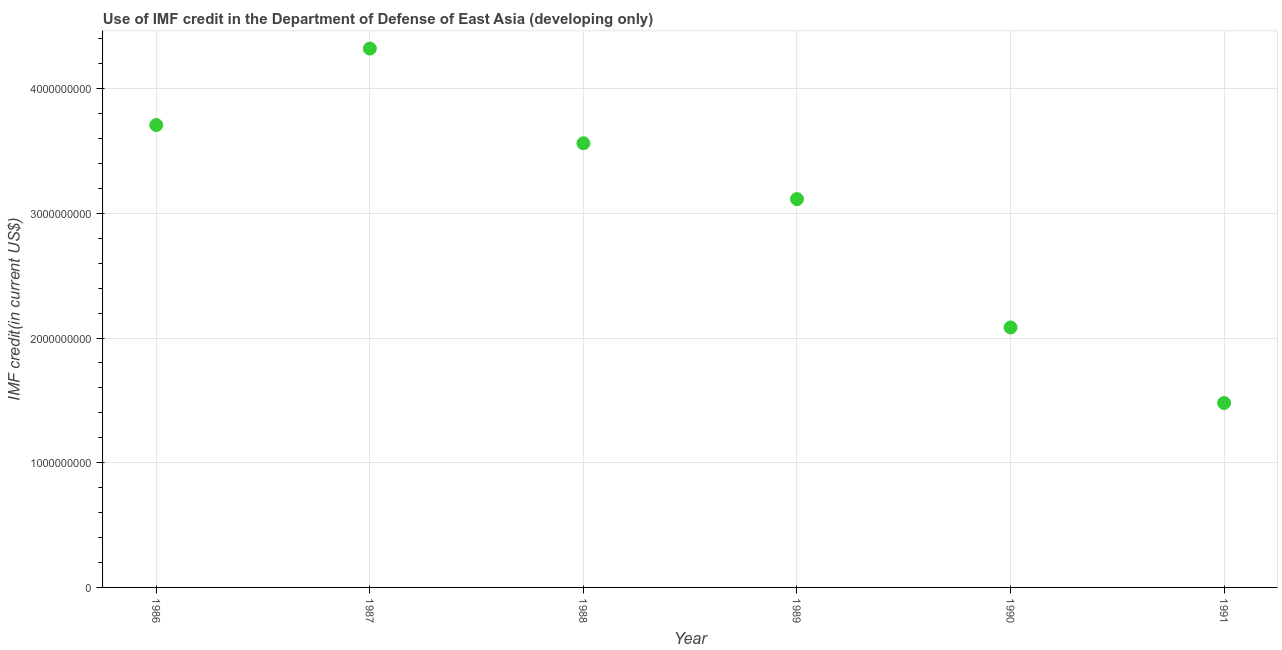What is the use of imf credit in dod in 1990?
Your answer should be very brief. 2.08e+09. Across all years, what is the maximum use of imf credit in dod?
Provide a succinct answer. 4.32e+09. Across all years, what is the minimum use of imf credit in dod?
Offer a very short reply. 1.48e+09. In which year was the use of imf credit in dod maximum?
Provide a succinct answer. 1987. In which year was the use of imf credit in dod minimum?
Keep it short and to the point. 1991. What is the sum of the use of imf credit in dod?
Ensure brevity in your answer.  1.83e+1. What is the difference between the use of imf credit in dod in 1989 and 1991?
Keep it short and to the point. 1.64e+09. What is the average use of imf credit in dod per year?
Your answer should be compact. 3.04e+09. What is the median use of imf credit in dod?
Provide a short and direct response. 3.34e+09. In how many years, is the use of imf credit in dod greater than 1400000000 US$?
Ensure brevity in your answer.  6. What is the ratio of the use of imf credit in dod in 1987 to that in 1990?
Provide a succinct answer. 2.07. What is the difference between the highest and the second highest use of imf credit in dod?
Make the answer very short. 6.14e+08. What is the difference between the highest and the lowest use of imf credit in dod?
Make the answer very short. 2.84e+09. In how many years, is the use of imf credit in dod greater than the average use of imf credit in dod taken over all years?
Provide a short and direct response. 4. How many years are there in the graph?
Your answer should be compact. 6. Does the graph contain grids?
Provide a short and direct response. Yes. What is the title of the graph?
Provide a succinct answer. Use of IMF credit in the Department of Defense of East Asia (developing only). What is the label or title of the X-axis?
Your response must be concise. Year. What is the label or title of the Y-axis?
Ensure brevity in your answer.  IMF credit(in current US$). What is the IMF credit(in current US$) in 1986?
Give a very brief answer. 3.71e+09. What is the IMF credit(in current US$) in 1987?
Provide a succinct answer. 4.32e+09. What is the IMF credit(in current US$) in 1988?
Provide a succinct answer. 3.56e+09. What is the IMF credit(in current US$) in 1989?
Provide a succinct answer. 3.11e+09. What is the IMF credit(in current US$) in 1990?
Your response must be concise. 2.08e+09. What is the IMF credit(in current US$) in 1991?
Offer a terse response. 1.48e+09. What is the difference between the IMF credit(in current US$) in 1986 and 1987?
Offer a terse response. -6.14e+08. What is the difference between the IMF credit(in current US$) in 1986 and 1988?
Ensure brevity in your answer.  1.46e+08. What is the difference between the IMF credit(in current US$) in 1986 and 1989?
Keep it short and to the point. 5.94e+08. What is the difference between the IMF credit(in current US$) in 1986 and 1990?
Provide a short and direct response. 1.62e+09. What is the difference between the IMF credit(in current US$) in 1986 and 1991?
Ensure brevity in your answer.  2.23e+09. What is the difference between the IMF credit(in current US$) in 1987 and 1988?
Keep it short and to the point. 7.60e+08. What is the difference between the IMF credit(in current US$) in 1987 and 1989?
Offer a very short reply. 1.21e+09. What is the difference between the IMF credit(in current US$) in 1987 and 1990?
Your response must be concise. 2.24e+09. What is the difference between the IMF credit(in current US$) in 1987 and 1991?
Keep it short and to the point. 2.84e+09. What is the difference between the IMF credit(in current US$) in 1988 and 1989?
Your response must be concise. 4.48e+08. What is the difference between the IMF credit(in current US$) in 1988 and 1990?
Your response must be concise. 1.48e+09. What is the difference between the IMF credit(in current US$) in 1988 and 1991?
Offer a terse response. 2.08e+09. What is the difference between the IMF credit(in current US$) in 1989 and 1990?
Offer a terse response. 1.03e+09. What is the difference between the IMF credit(in current US$) in 1989 and 1991?
Give a very brief answer. 1.64e+09. What is the difference between the IMF credit(in current US$) in 1990 and 1991?
Provide a succinct answer. 6.06e+08. What is the ratio of the IMF credit(in current US$) in 1986 to that in 1987?
Offer a terse response. 0.86. What is the ratio of the IMF credit(in current US$) in 1986 to that in 1988?
Offer a very short reply. 1.04. What is the ratio of the IMF credit(in current US$) in 1986 to that in 1989?
Your response must be concise. 1.19. What is the ratio of the IMF credit(in current US$) in 1986 to that in 1990?
Keep it short and to the point. 1.78. What is the ratio of the IMF credit(in current US$) in 1986 to that in 1991?
Give a very brief answer. 2.51. What is the ratio of the IMF credit(in current US$) in 1987 to that in 1988?
Give a very brief answer. 1.21. What is the ratio of the IMF credit(in current US$) in 1987 to that in 1989?
Provide a short and direct response. 1.39. What is the ratio of the IMF credit(in current US$) in 1987 to that in 1990?
Provide a succinct answer. 2.07. What is the ratio of the IMF credit(in current US$) in 1987 to that in 1991?
Provide a short and direct response. 2.92. What is the ratio of the IMF credit(in current US$) in 1988 to that in 1989?
Give a very brief answer. 1.14. What is the ratio of the IMF credit(in current US$) in 1988 to that in 1990?
Your response must be concise. 1.71. What is the ratio of the IMF credit(in current US$) in 1988 to that in 1991?
Your answer should be compact. 2.41. What is the ratio of the IMF credit(in current US$) in 1989 to that in 1990?
Provide a succinct answer. 1.49. What is the ratio of the IMF credit(in current US$) in 1989 to that in 1991?
Your answer should be compact. 2.11. What is the ratio of the IMF credit(in current US$) in 1990 to that in 1991?
Offer a terse response. 1.41. 